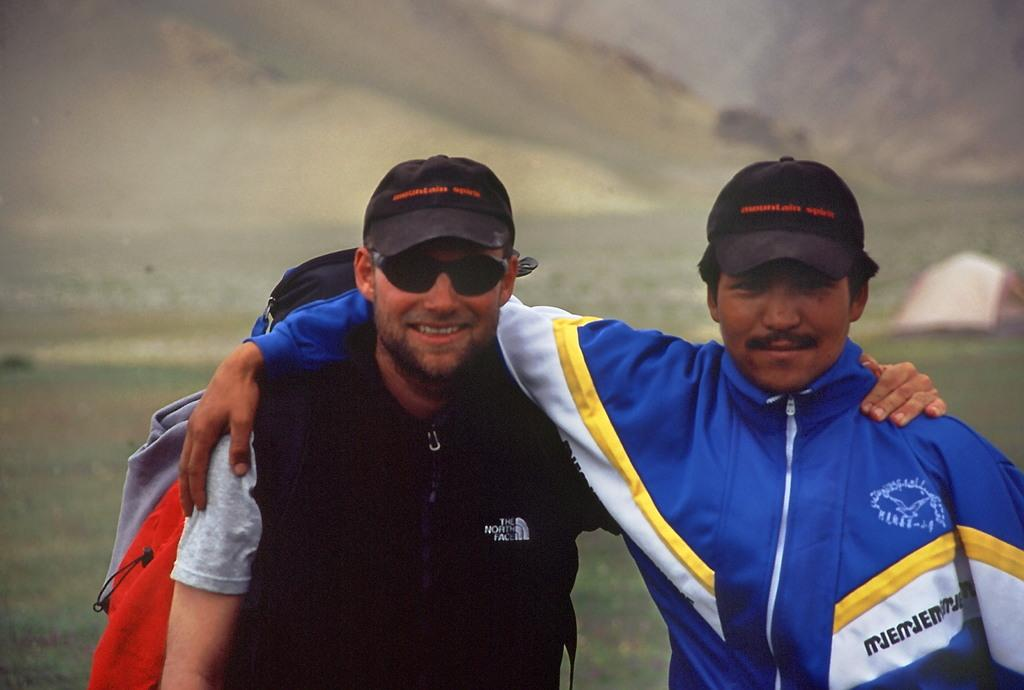How many people are in the image? There are two persons standing in the center of the image. What are the people wearing on their heads? Both persons are wearing black color caps. What can be seen in the background of the image? There is grass in the background of the image. What structure is visible to the right side of the image? There is a tent to the right side of the image. What historical event is being commemorated by the people in the image? There is no indication of a historical event being commemorated in the image. What is the size of the tent in the image? The size of the tent cannot be determined from the image alone, as there is no reference point for comparison. 